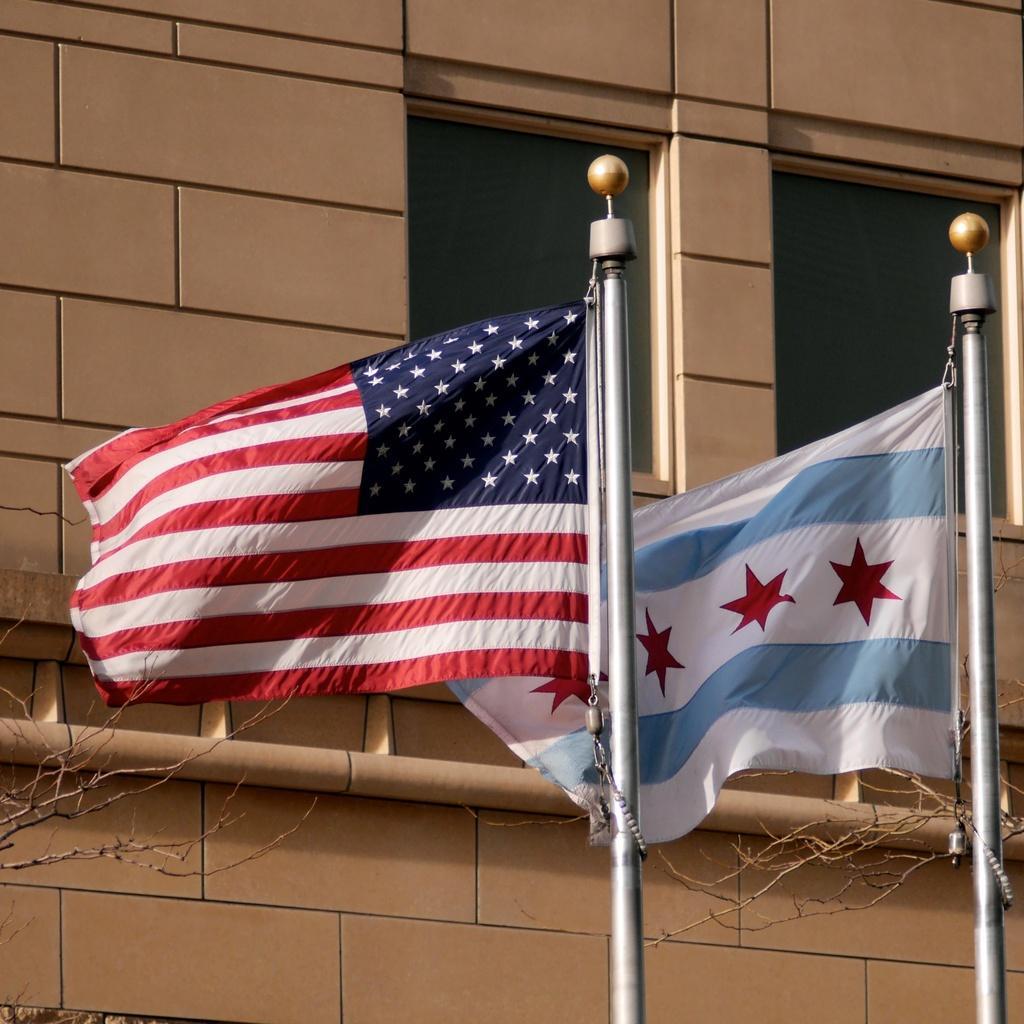Please provide a concise description of this image. In this image there are flags, poles, wall, windows, pipe and branches.   